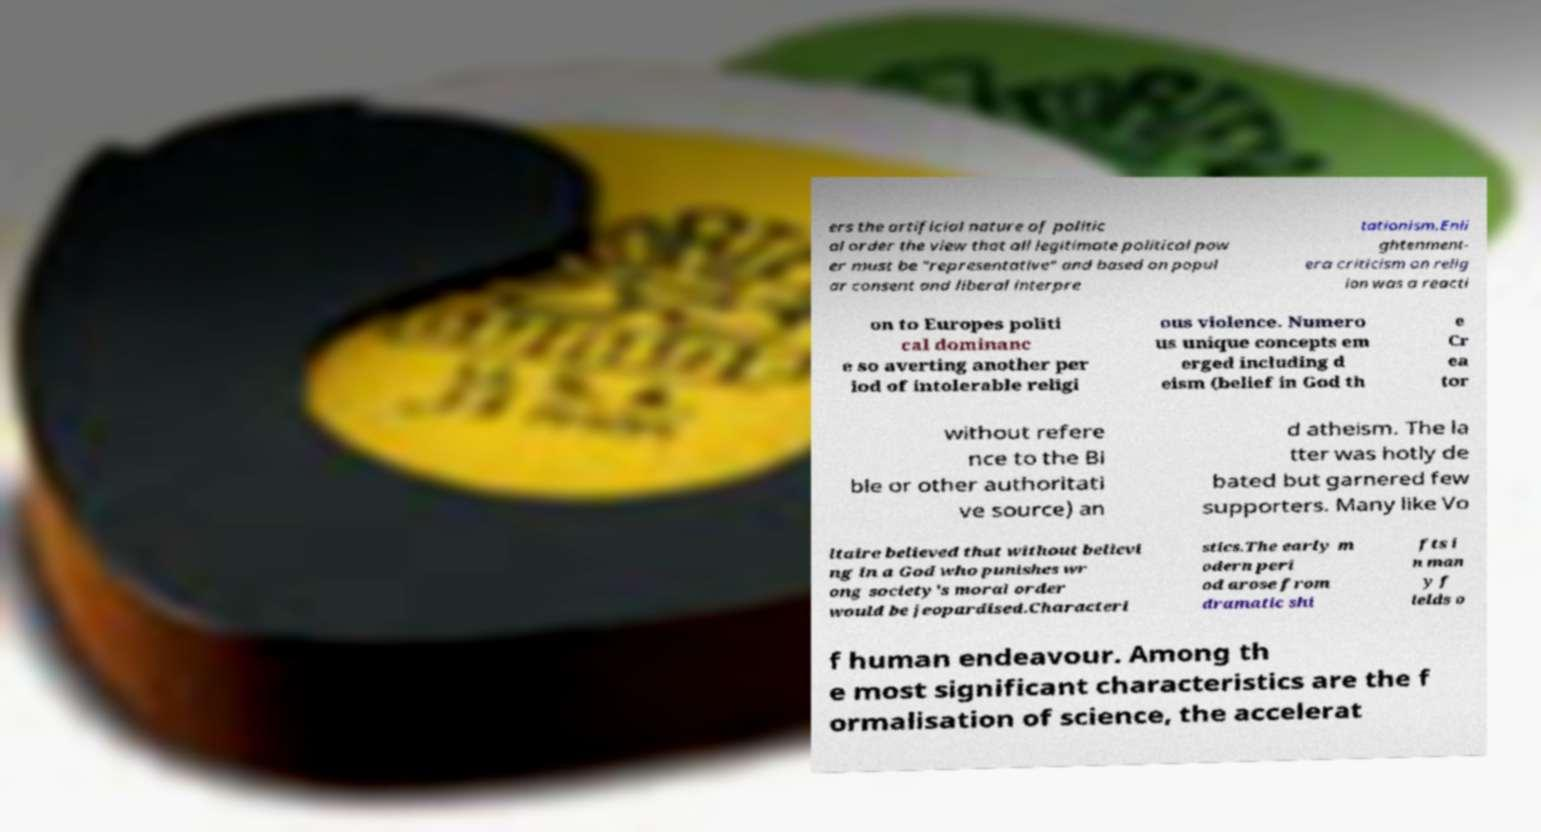There's text embedded in this image that I need extracted. Can you transcribe it verbatim? ers the artificial nature of politic al order the view that all legitimate political pow er must be "representative" and based on popul ar consent and liberal interpre tationism.Enli ghtenment- era criticism on relig ion was a reacti on to Europes politi cal dominanc e so averting another per iod of intolerable religi ous violence. Numero us unique concepts em erged including d eism (belief in God th e Cr ea tor without refere nce to the Bi ble or other authoritati ve source) an d atheism. The la tter was hotly de bated but garnered few supporters. Many like Vo ltaire believed that without believi ng in a God who punishes wr ong society's moral order would be jeopardised.Characteri stics.The early m odern peri od arose from dramatic shi fts i n man y f ields o f human endeavour. Among th e most significant characteristics are the f ormalisation of science, the accelerat 